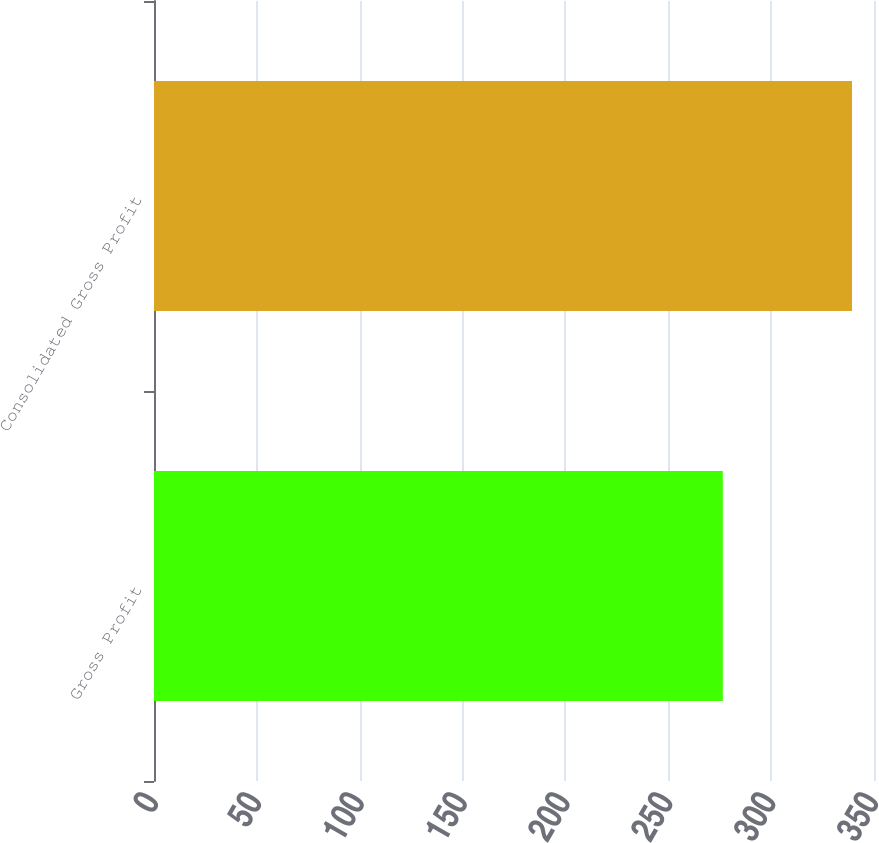Convert chart to OTSL. <chart><loc_0><loc_0><loc_500><loc_500><bar_chart><fcel>Gross Profit<fcel>Consolidated Gross Profit<nl><fcel>276.5<fcel>339.3<nl></chart> 